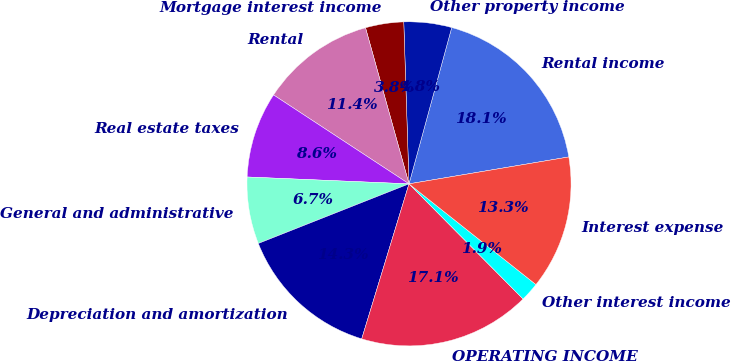<chart> <loc_0><loc_0><loc_500><loc_500><pie_chart><fcel>Rental income<fcel>Other property income<fcel>Mortgage interest income<fcel>Rental<fcel>Real estate taxes<fcel>General and administrative<fcel>Depreciation and amortization<fcel>OPERATING INCOME<fcel>Other interest income<fcel>Interest expense<nl><fcel>18.1%<fcel>4.76%<fcel>3.81%<fcel>11.43%<fcel>8.57%<fcel>6.67%<fcel>14.29%<fcel>17.14%<fcel>1.9%<fcel>13.33%<nl></chart> 